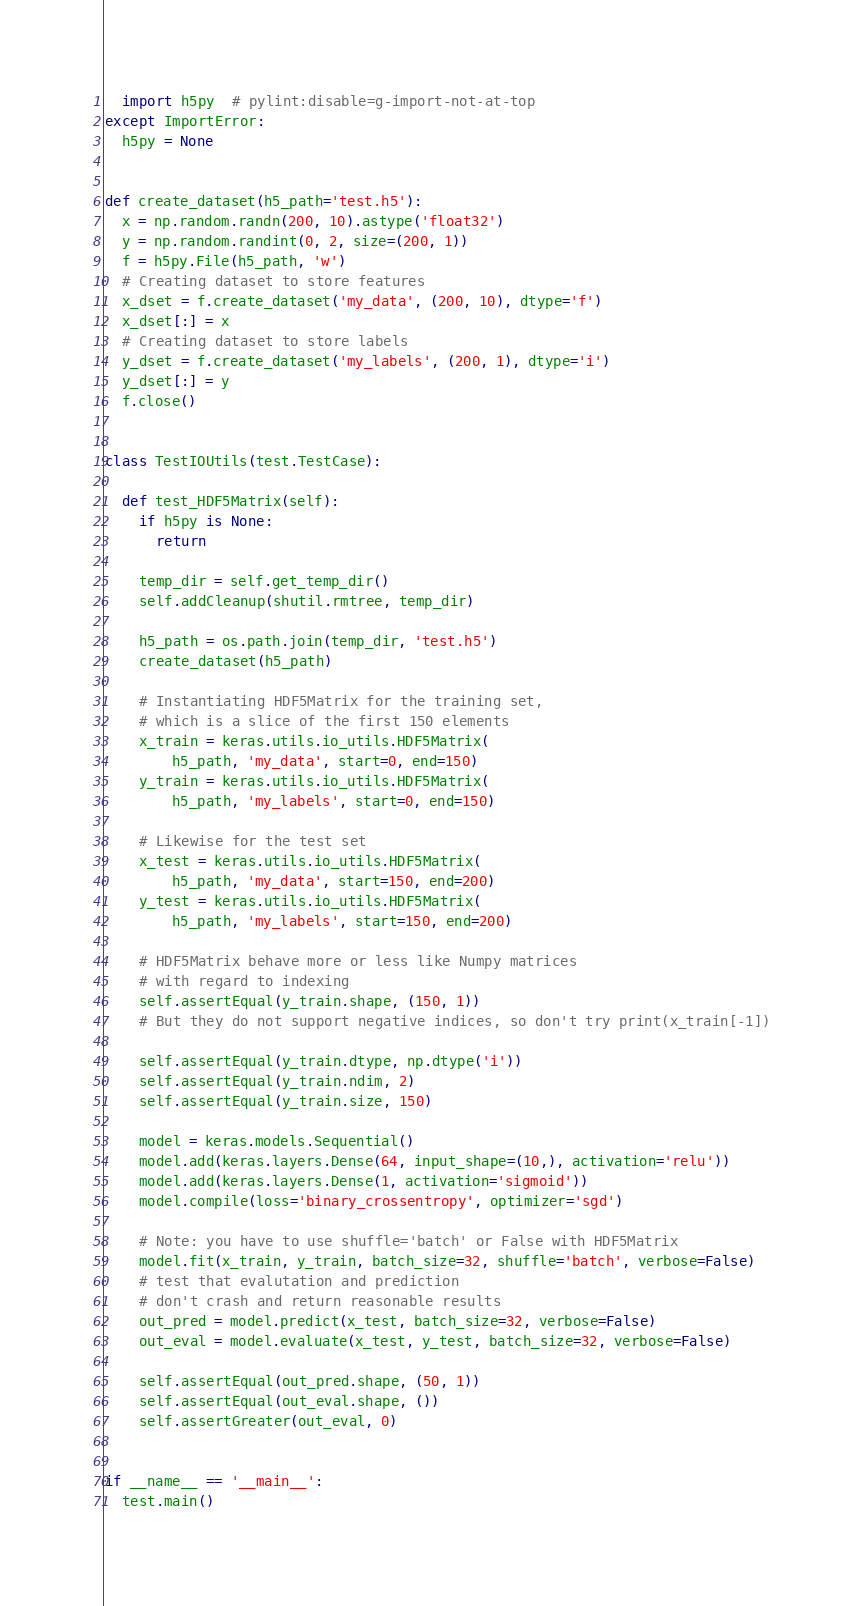Convert code to text. <code><loc_0><loc_0><loc_500><loc_500><_Python_>  import h5py  # pylint:disable=g-import-not-at-top
except ImportError:
  h5py = None


def create_dataset(h5_path='test.h5'):
  x = np.random.randn(200, 10).astype('float32')
  y = np.random.randint(0, 2, size=(200, 1))
  f = h5py.File(h5_path, 'w')
  # Creating dataset to store features
  x_dset = f.create_dataset('my_data', (200, 10), dtype='f')
  x_dset[:] = x
  # Creating dataset to store labels
  y_dset = f.create_dataset('my_labels', (200, 1), dtype='i')
  y_dset[:] = y
  f.close()


class TestIOUtils(test.TestCase):

  def test_HDF5Matrix(self):
    if h5py is None:
      return

    temp_dir = self.get_temp_dir()
    self.addCleanup(shutil.rmtree, temp_dir)

    h5_path = os.path.join(temp_dir, 'test.h5')
    create_dataset(h5_path)

    # Instantiating HDF5Matrix for the training set,
    # which is a slice of the first 150 elements
    x_train = keras.utils.io_utils.HDF5Matrix(
        h5_path, 'my_data', start=0, end=150)
    y_train = keras.utils.io_utils.HDF5Matrix(
        h5_path, 'my_labels', start=0, end=150)

    # Likewise for the test set
    x_test = keras.utils.io_utils.HDF5Matrix(
        h5_path, 'my_data', start=150, end=200)
    y_test = keras.utils.io_utils.HDF5Matrix(
        h5_path, 'my_labels', start=150, end=200)

    # HDF5Matrix behave more or less like Numpy matrices
    # with regard to indexing
    self.assertEqual(y_train.shape, (150, 1))
    # But they do not support negative indices, so don't try print(x_train[-1])

    self.assertEqual(y_train.dtype, np.dtype('i'))
    self.assertEqual(y_train.ndim, 2)
    self.assertEqual(y_train.size, 150)

    model = keras.models.Sequential()
    model.add(keras.layers.Dense(64, input_shape=(10,), activation='relu'))
    model.add(keras.layers.Dense(1, activation='sigmoid'))
    model.compile(loss='binary_crossentropy', optimizer='sgd')

    # Note: you have to use shuffle='batch' or False with HDF5Matrix
    model.fit(x_train, y_train, batch_size=32, shuffle='batch', verbose=False)
    # test that evalutation and prediction
    # don't crash and return reasonable results
    out_pred = model.predict(x_test, batch_size=32, verbose=False)
    out_eval = model.evaluate(x_test, y_test, batch_size=32, verbose=False)

    self.assertEqual(out_pred.shape, (50, 1))
    self.assertEqual(out_eval.shape, ())
    self.assertGreater(out_eval, 0)


if __name__ == '__main__':
  test.main()
</code> 